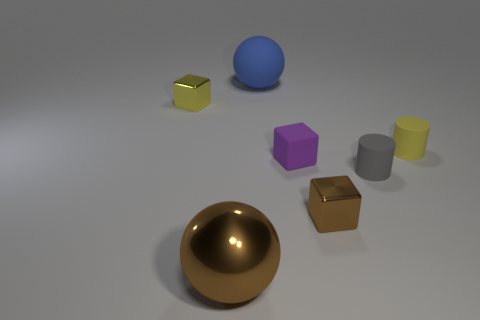What does the arrangement of these objects tell us? The objects are arrayed in no specific order, which suggests they might have been placed randomly or for the purpose of displaying different geometric shapes and colors, possibly for an educational or illustrative purpose. 